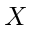Convert formula to latex. <formula><loc_0><loc_0><loc_500><loc_500>X</formula> 